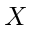Convert formula to latex. <formula><loc_0><loc_0><loc_500><loc_500>X</formula> 